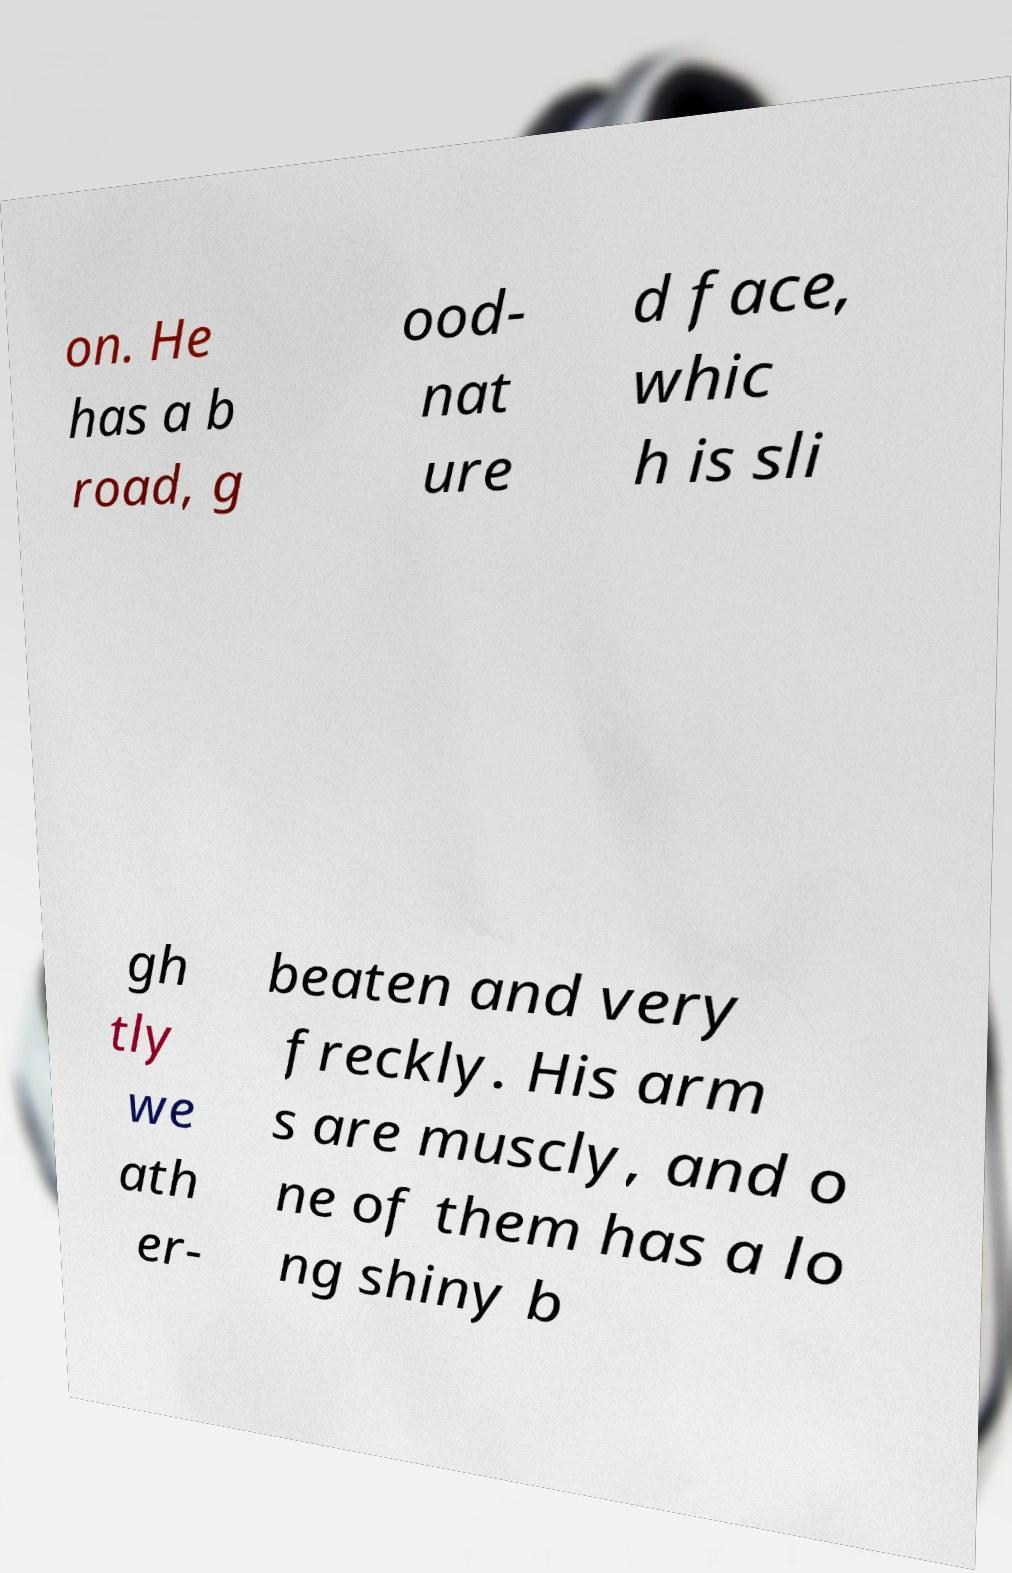There's text embedded in this image that I need extracted. Can you transcribe it verbatim? on. He has a b road, g ood- nat ure d face, whic h is sli gh tly we ath er- beaten and very freckly. His arm s are muscly, and o ne of them has a lo ng shiny b 